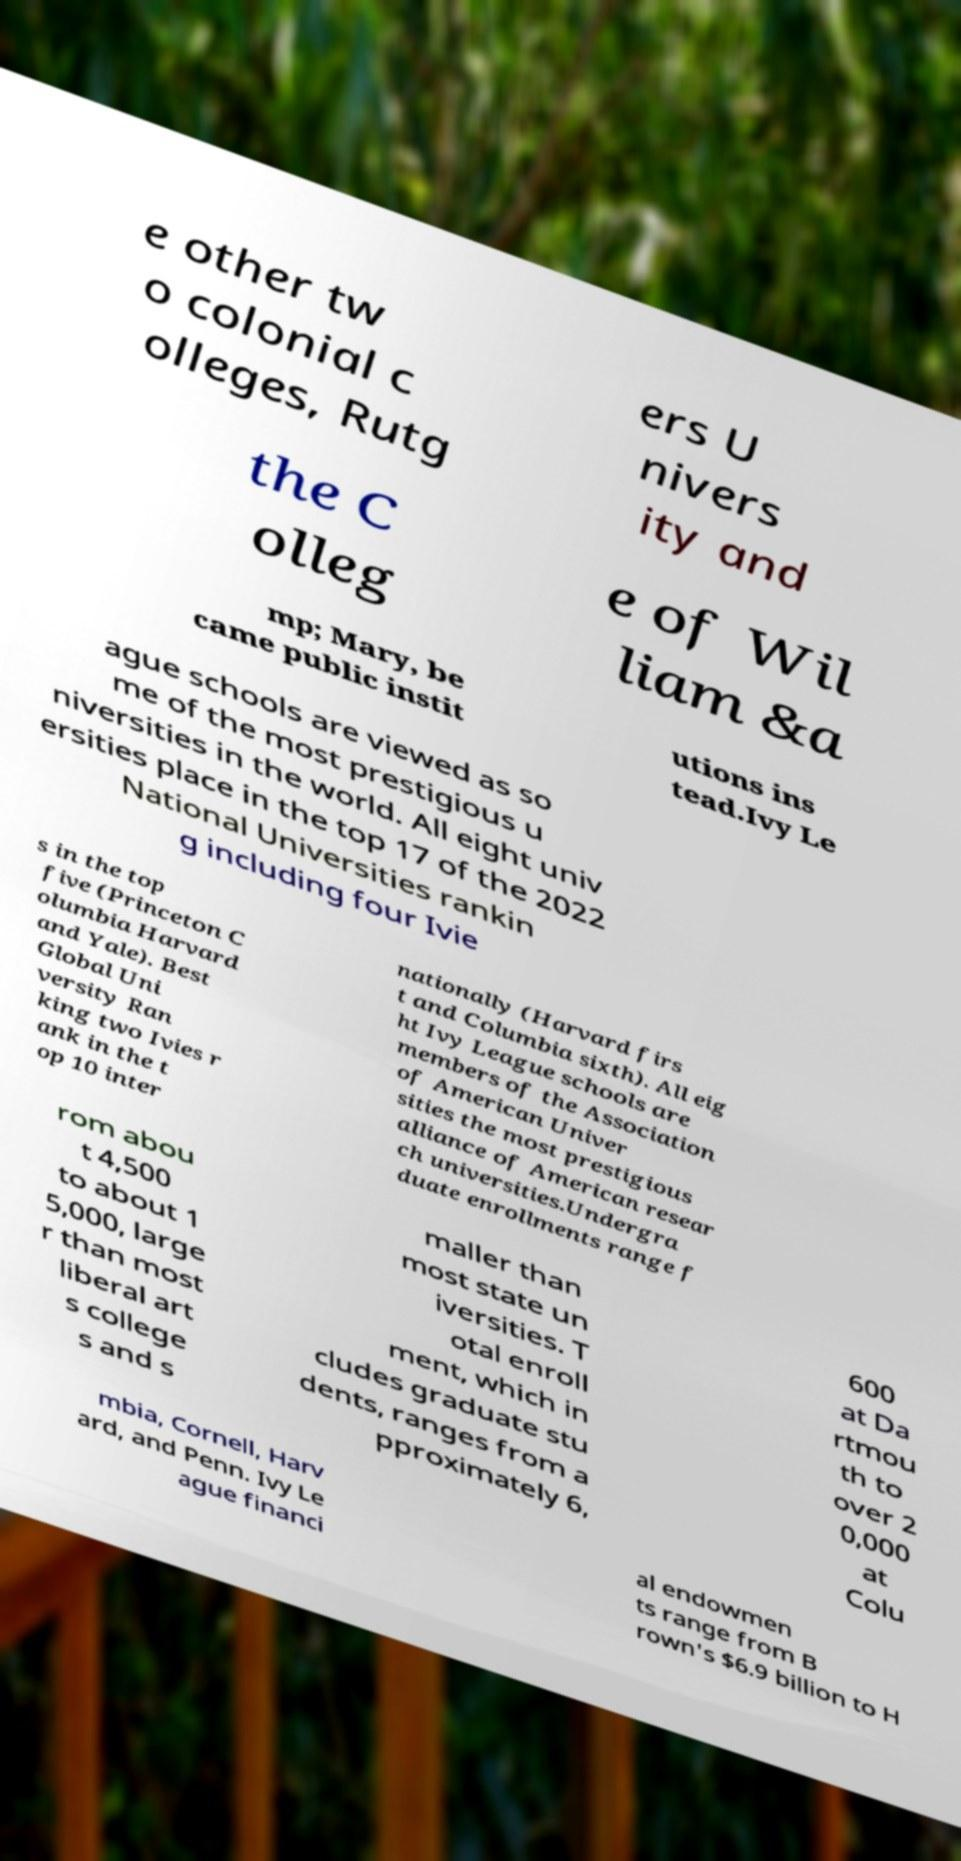Please read and relay the text visible in this image. What does it say? e other tw o colonial c olleges, Rutg ers U nivers ity and the C olleg e of Wil liam &a mp; Mary, be came public instit utions ins tead.Ivy Le ague schools are viewed as so me of the most prestigious u niversities in the world. All eight univ ersities place in the top 17 of the 2022 National Universities rankin g including four Ivie s in the top five (Princeton C olumbia Harvard and Yale). Best Global Uni versity Ran king two Ivies r ank in the t op 10 inter nationally (Harvard firs t and Columbia sixth). All eig ht Ivy League schools are members of the Association of American Univer sities the most prestigious alliance of American resear ch universities.Undergra duate enrollments range f rom abou t 4,500 to about 1 5,000, large r than most liberal art s college s and s maller than most state un iversities. T otal enroll ment, which in cludes graduate stu dents, ranges from a pproximately 6, 600 at Da rtmou th to over 2 0,000 at Colu mbia, Cornell, Harv ard, and Penn. Ivy Le ague financi al endowmen ts range from B rown's $6.9 billion to H 